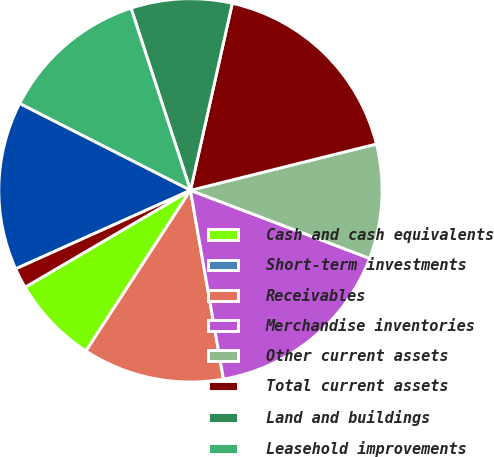<chart> <loc_0><loc_0><loc_500><loc_500><pie_chart><fcel>Cash and cash equivalents<fcel>Short-term investments<fcel>Receivables<fcel>Merchandise inventories<fcel>Other current assets<fcel>Total current assets<fcel>Land and buildings<fcel>Leasehold improvements<fcel>Fixtures and equipment<fcel>Property under capital lease<nl><fcel>7.39%<fcel>0.0%<fcel>11.93%<fcel>16.47%<fcel>9.66%<fcel>17.61%<fcel>8.52%<fcel>12.5%<fcel>14.2%<fcel>1.71%<nl></chart> 